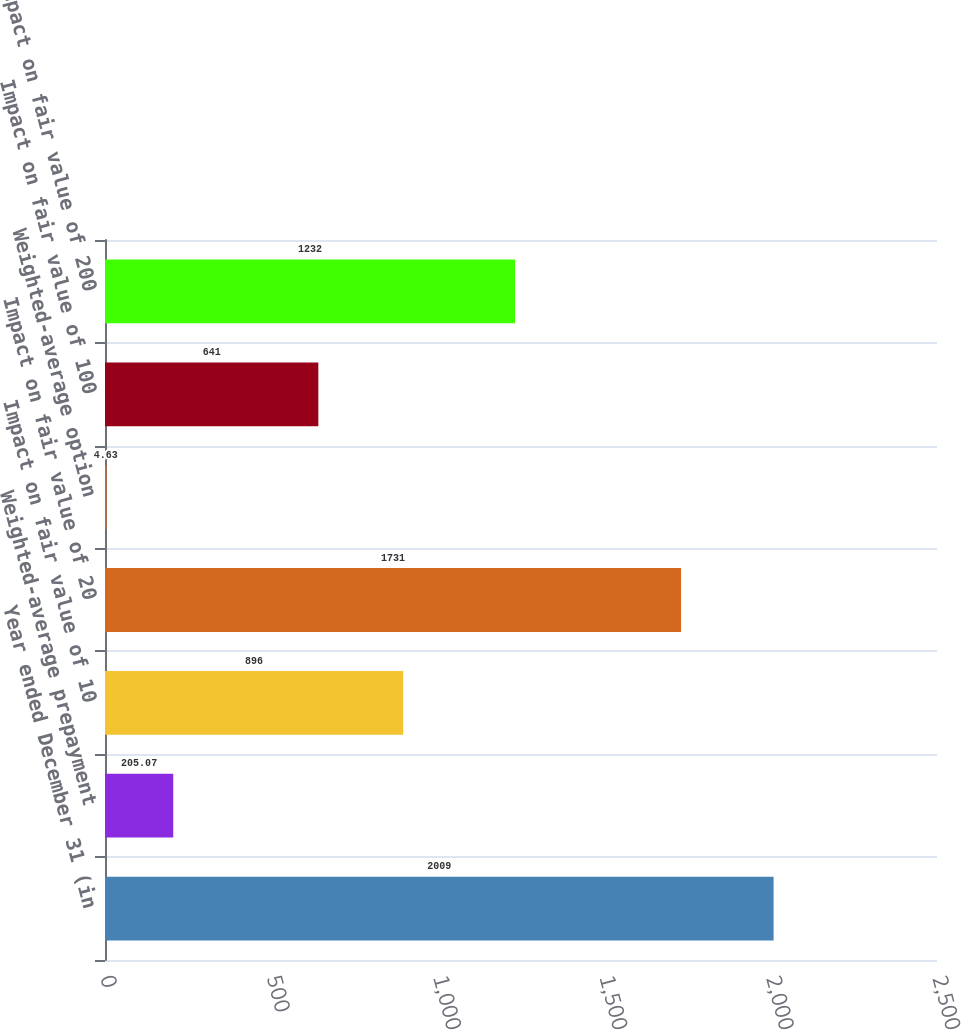Convert chart to OTSL. <chart><loc_0><loc_0><loc_500><loc_500><bar_chart><fcel>Year ended December 31 (in<fcel>Weighted-average prepayment<fcel>Impact on fair value of 10<fcel>Impact on fair value of 20<fcel>Weighted-average option<fcel>Impact on fair value of 100<fcel>Impact on fair value of 200<nl><fcel>2009<fcel>205.07<fcel>896<fcel>1731<fcel>4.63<fcel>641<fcel>1232<nl></chart> 